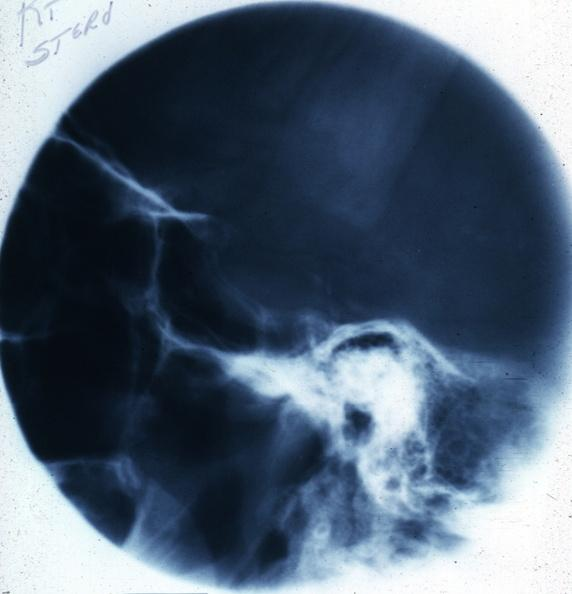what is present?
Answer the question using a single word or phrase. Pituitary 